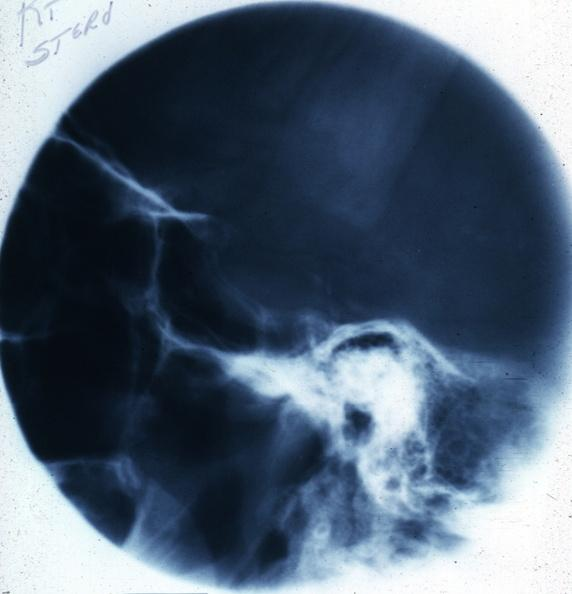what is present?
Answer the question using a single word or phrase. Pituitary 